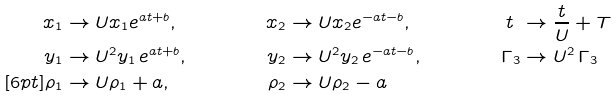Convert formula to latex. <formula><loc_0><loc_0><loc_500><loc_500>x _ { 1 } & \rightarrow U x _ { 1 } e ^ { a t + b } , & x _ { 2 } & \rightarrow U x _ { 2 } e ^ { - a t - b } , & t \ & \rightarrow \frac { t } { U } + T & \\ y _ { 1 } & \rightarrow U ^ { 2 } y _ { 1 } \, e ^ { a t + b } , & y _ { 2 } & \rightarrow U ^ { 2 } y _ { 2 } \, e ^ { - a t - b } , & \Gamma _ { 3 } & \rightarrow U ^ { 2 } \, \Gamma _ { 3 } & \\ [ 6 p t ] \rho _ { 1 } & \rightarrow U \rho _ { 1 } + a , & \rho _ { 2 } & \rightarrow U \rho _ { 2 } - a & &</formula> 